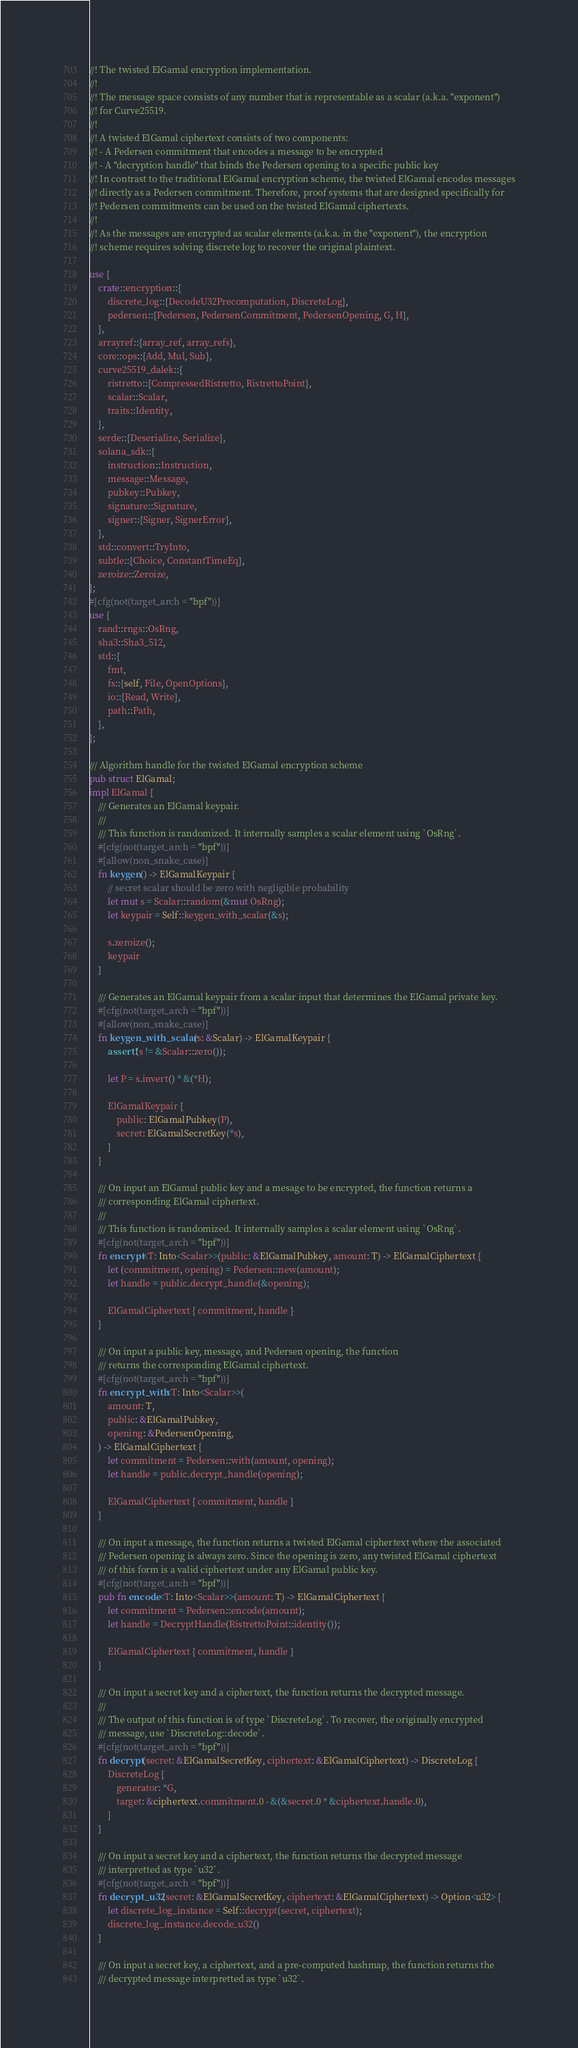Convert code to text. <code><loc_0><loc_0><loc_500><loc_500><_Rust_>//! The twisted ElGamal encryption implementation.
//!
//! The message space consists of any number that is representable as a scalar (a.k.a. "exponent")
//! for Curve25519.
//!
//! A twisted ElGamal ciphertext consists of two components:
//! - A Pedersen commitment that encodes a message to be encrypted
//! - A "decryption handle" that binds the Pedersen opening to a specific public key
//! In contrast to the traditional ElGamal encryption scheme, the twisted ElGamal encodes messages
//! directly as a Pedersen commitment. Therefore, proof systems that are designed specifically for
//! Pedersen commitments can be used on the twisted ElGamal ciphertexts.
//!
//! As the messages are encrypted as scalar elements (a.k.a. in the "exponent"), the encryption
//! scheme requires solving discrete log to recover the original plaintext.

use {
    crate::encryption::{
        discrete_log::{DecodeU32Precomputation, DiscreteLog},
        pedersen::{Pedersen, PedersenCommitment, PedersenOpening, G, H},
    },
    arrayref::{array_ref, array_refs},
    core::ops::{Add, Mul, Sub},
    curve25519_dalek::{
        ristretto::{CompressedRistretto, RistrettoPoint},
        scalar::Scalar,
        traits::Identity,
    },
    serde::{Deserialize, Serialize},
    solana_sdk::{
        instruction::Instruction,
        message::Message,
        pubkey::Pubkey,
        signature::Signature,
        signer::{Signer, SignerError},
    },
    std::convert::TryInto,
    subtle::{Choice, ConstantTimeEq},
    zeroize::Zeroize,
};
#[cfg(not(target_arch = "bpf"))]
use {
    rand::rngs::OsRng,
    sha3::Sha3_512,
    std::{
        fmt,
        fs::{self, File, OpenOptions},
        io::{Read, Write},
        path::Path,
    },
};

/// Algorithm handle for the twisted ElGamal encryption scheme
pub struct ElGamal;
impl ElGamal {
    /// Generates an ElGamal keypair.
    ///
    /// This function is randomized. It internally samples a scalar element using `OsRng`.
    #[cfg(not(target_arch = "bpf"))]
    #[allow(non_snake_case)]
    fn keygen() -> ElGamalKeypair {
        // secret scalar should be zero with negligible probability
        let mut s = Scalar::random(&mut OsRng);
        let keypair = Self::keygen_with_scalar(&s);

        s.zeroize();
        keypair
    }

    /// Generates an ElGamal keypair from a scalar input that determines the ElGamal private key.
    #[cfg(not(target_arch = "bpf"))]
    #[allow(non_snake_case)]
    fn keygen_with_scalar(s: &Scalar) -> ElGamalKeypair {
        assert!(s != &Scalar::zero());

        let P = s.invert() * &(*H);

        ElGamalKeypair {
            public: ElGamalPubkey(P),
            secret: ElGamalSecretKey(*s),
        }
    }

    /// On input an ElGamal public key and a mesage to be encrypted, the function returns a
    /// corresponding ElGamal ciphertext.
    ///
    /// This function is randomized. It internally samples a scalar element using `OsRng`.
    #[cfg(not(target_arch = "bpf"))]
    fn encrypt<T: Into<Scalar>>(public: &ElGamalPubkey, amount: T) -> ElGamalCiphertext {
        let (commitment, opening) = Pedersen::new(amount);
        let handle = public.decrypt_handle(&opening);

        ElGamalCiphertext { commitment, handle }
    }

    /// On input a public key, message, and Pedersen opening, the function
    /// returns the corresponding ElGamal ciphertext.
    #[cfg(not(target_arch = "bpf"))]
    fn encrypt_with<T: Into<Scalar>>(
        amount: T,
        public: &ElGamalPubkey,
        opening: &PedersenOpening,
    ) -> ElGamalCiphertext {
        let commitment = Pedersen::with(amount, opening);
        let handle = public.decrypt_handle(opening);

        ElGamalCiphertext { commitment, handle }
    }

    /// On input a message, the function returns a twisted ElGamal ciphertext where the associated
    /// Pedersen opening is always zero. Since the opening is zero, any twisted ElGamal ciphertext
    /// of this form is a valid ciphertext under any ElGamal public key.
    #[cfg(not(target_arch = "bpf"))]
    pub fn encode<T: Into<Scalar>>(amount: T) -> ElGamalCiphertext {
        let commitment = Pedersen::encode(amount);
        let handle = DecryptHandle(RistrettoPoint::identity());

        ElGamalCiphertext { commitment, handle }
    }

    /// On input a secret key and a ciphertext, the function returns the decrypted message.
    ///
    /// The output of this function is of type `DiscreteLog`. To recover, the originally encrypted
    /// message, use `DiscreteLog::decode`.
    #[cfg(not(target_arch = "bpf"))]
    fn decrypt(secret: &ElGamalSecretKey, ciphertext: &ElGamalCiphertext) -> DiscreteLog {
        DiscreteLog {
            generator: *G,
            target: &ciphertext.commitment.0 - &(&secret.0 * &ciphertext.handle.0),
        }
    }

    /// On input a secret key and a ciphertext, the function returns the decrypted message
    /// interpretted as type `u32`.
    #[cfg(not(target_arch = "bpf"))]
    fn decrypt_u32(secret: &ElGamalSecretKey, ciphertext: &ElGamalCiphertext) -> Option<u32> {
        let discrete_log_instance = Self::decrypt(secret, ciphertext);
        discrete_log_instance.decode_u32()
    }

    /// On input a secret key, a ciphertext, and a pre-computed hashmap, the function returns the
    /// decrypted message interpretted as type `u32`.</code> 